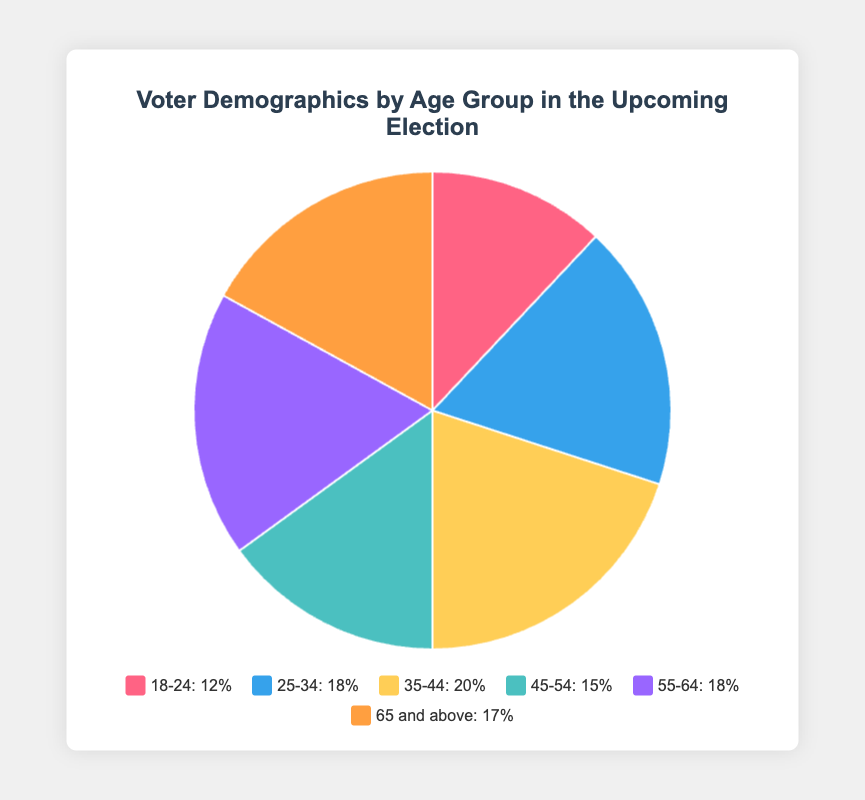Which age group has the highest percentage of voters? According to the pie chart, the age group 35-44 has the highest percentage of voters. It is evident because the largest slice of the pie is colored to represent this age group. The legend confirms that 35-44 accounts for 20%.
Answer: 35-44 Which two age groups have an equal percentage of voters? By examining the pie chart and the legend, we see that the age groups 25-34 and 55-64 both have the same percentage of voters, which is 18%.
Answer: 25-34 and 55-64 What is the total percentage of voters aged 18-44? Adding the percentages of the age groups 18-24, 25-34, and 35-44: 12% + 18% + 20% = 50%.
Answer: 50% Which is the least represented age group in the voter demographics? The age group 18-24 has the smallest slice in the pie chart, indicating it has the lowest percentage, which is 12%.
Answer: 18-24 How does the percentage of voters aged 65 and above compare to those aged 45-54? The legend shows that the age group 65 and above accounts for 17%, while the age group 45-54 accounts for 15%. Hence, the percentage of voters aged 65 and above is 2% higher than those aged 45-54.
Answer: 2% higher What percentage of voters fall within the 45-64 age range? Adding the percentages of the age groups 45-54 and 55-64: 15% + 18% = 33%.
Answer: 33% Which age group has a percentage closest to the average percentage of all age groups? First, we calculate the average: (12% + 18% + 20% + 15% + 18% + 17%) / 6 = 16.67%. The age group 45-54 has the closest percentage, which is 15%.
Answer: 45-54 If the age groups are ranked from highest to lowest percentage, what position does the age group 55-64 occupy? Ranking the age groups: 35-44 (20%), 25-34 (18%) and 55-64 (18%), 65 and above (17%), 45-54 (15%), 18-24 (12%). 55-64 ties for second place.
Answer: Second Which color represents the age group with the median percentage of voters? The median percentage is 17% (as the middle value in the sorted list). The age group 65 and above has a 17% share and it is represented by the color identified in the legend (a shade of orange).
Answer: Orange Is there an age group where the percentage equals the percentage of voters above 65? Yes, the age group 25-34 has an identical percentage (18%) as the group 55-64. The age group 45-54 does not match since it is 15%, and thus not equal.
Answer: Yes 